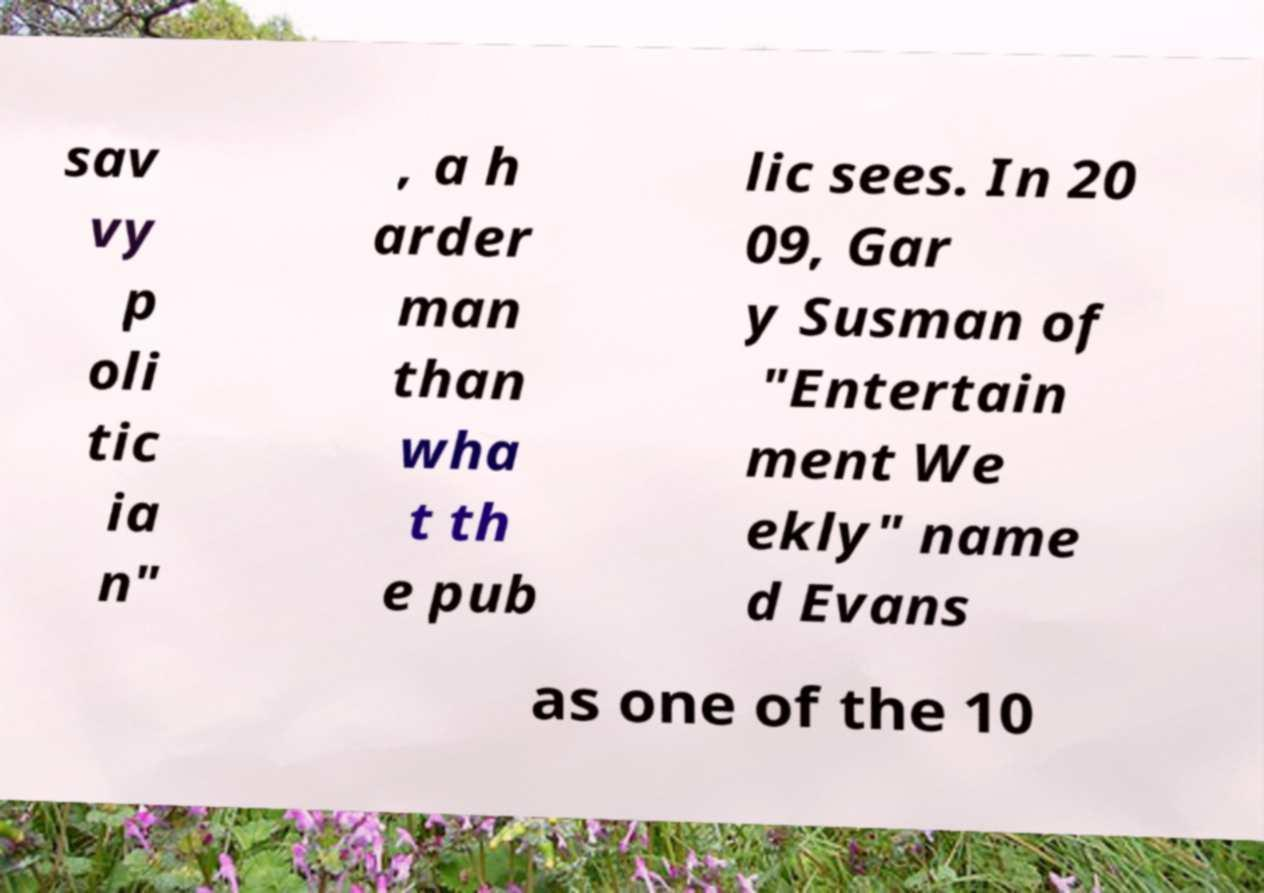Can you read and provide the text displayed in the image?This photo seems to have some interesting text. Can you extract and type it out for me? sav vy p oli tic ia n" , a h arder man than wha t th e pub lic sees. In 20 09, Gar y Susman of "Entertain ment We ekly" name d Evans as one of the 10 